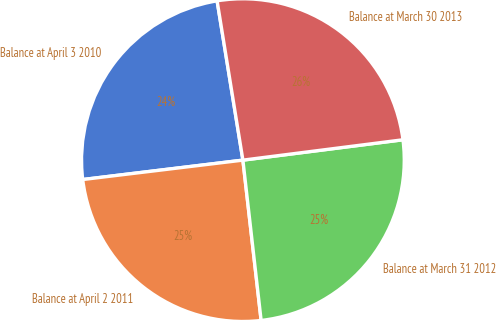Convert chart to OTSL. <chart><loc_0><loc_0><loc_500><loc_500><pie_chart><fcel>Balance at April 3 2010<fcel>Balance at April 2 2011<fcel>Balance at March 31 2012<fcel>Balance at March 30 2013<nl><fcel>24.36%<fcel>24.88%<fcel>25.21%<fcel>25.54%<nl></chart> 